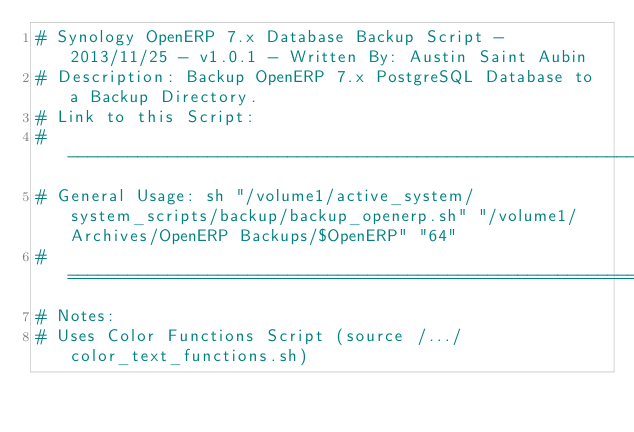Convert code to text. <code><loc_0><loc_0><loc_500><loc_500><_Bash_># Synology OpenERP 7.x Database Backup Script - 2013/11/25 - v1.0.1 - Written By: Austin Saint Aubin
# Description: Backup OpenERP 7.x PostgreSQL Database to a Backup Directory.
# Link to this Script: 
# -------------------------------------------------------------------------------------------------
# General Usage: sh "/volume1/active_system/system_scripts/backup/backup_openerp.sh" "/volume1/Archives/OpenERP Backups/$OpenERP" "64"
# =================================================================================================
# Notes:
#	Uses Color Functions Script (source /.../color_text_functions.sh)</code> 